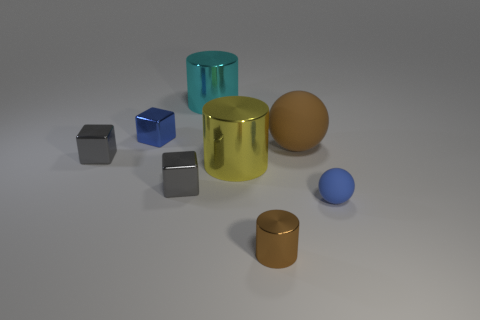Add 2 cyan shiny cylinders. How many objects exist? 10 Subtract all cubes. How many objects are left? 5 Add 2 tiny blue shiny objects. How many tiny blue shiny objects are left? 3 Add 7 small blue balls. How many small blue balls exist? 8 Subtract 0 green cylinders. How many objects are left? 8 Subtract all gray metal things. Subtract all big yellow metallic cylinders. How many objects are left? 5 